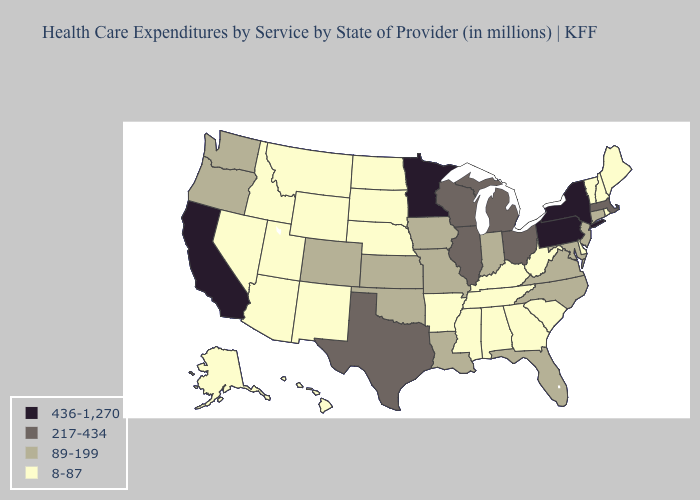What is the highest value in the Northeast ?
Be succinct. 436-1,270. What is the highest value in the West ?
Keep it brief. 436-1,270. Does South Dakota have a lower value than New Mexico?
Write a very short answer. No. What is the value of Oklahoma?
Be succinct. 89-199. Name the states that have a value in the range 89-199?
Write a very short answer. Colorado, Connecticut, Florida, Indiana, Iowa, Kansas, Louisiana, Maryland, Missouri, New Jersey, North Carolina, Oklahoma, Oregon, Virginia, Washington. What is the lowest value in the USA?
Be succinct. 8-87. Name the states that have a value in the range 217-434?
Concise answer only. Illinois, Massachusetts, Michigan, Ohio, Texas, Wisconsin. What is the highest value in states that border Pennsylvania?
Be succinct. 436-1,270. Name the states that have a value in the range 8-87?
Concise answer only. Alabama, Alaska, Arizona, Arkansas, Delaware, Georgia, Hawaii, Idaho, Kentucky, Maine, Mississippi, Montana, Nebraska, Nevada, New Hampshire, New Mexico, North Dakota, Rhode Island, South Carolina, South Dakota, Tennessee, Utah, Vermont, West Virginia, Wyoming. Name the states that have a value in the range 8-87?
Answer briefly. Alabama, Alaska, Arizona, Arkansas, Delaware, Georgia, Hawaii, Idaho, Kentucky, Maine, Mississippi, Montana, Nebraska, Nevada, New Hampshire, New Mexico, North Dakota, Rhode Island, South Carolina, South Dakota, Tennessee, Utah, Vermont, West Virginia, Wyoming. Does Wyoming have the lowest value in the West?
Quick response, please. Yes. Which states have the highest value in the USA?
Write a very short answer. California, Minnesota, New York, Pennsylvania. Which states hav the highest value in the MidWest?
Write a very short answer. Minnesota. What is the highest value in states that border Texas?
Keep it brief. 89-199. 